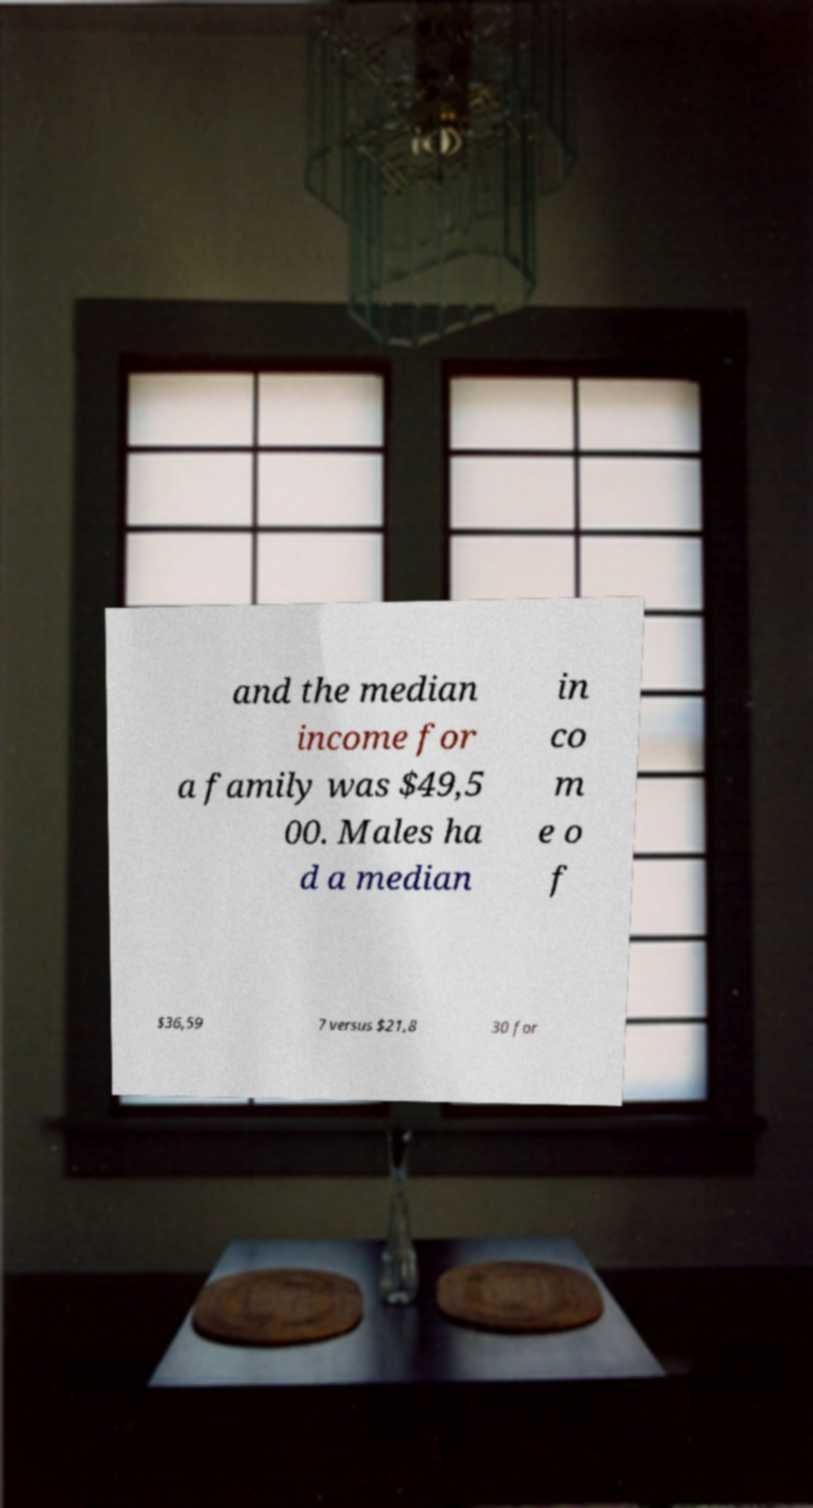Can you accurately transcribe the text from the provided image for me? and the median income for a family was $49,5 00. Males ha d a median in co m e o f $36,59 7 versus $21,8 30 for 